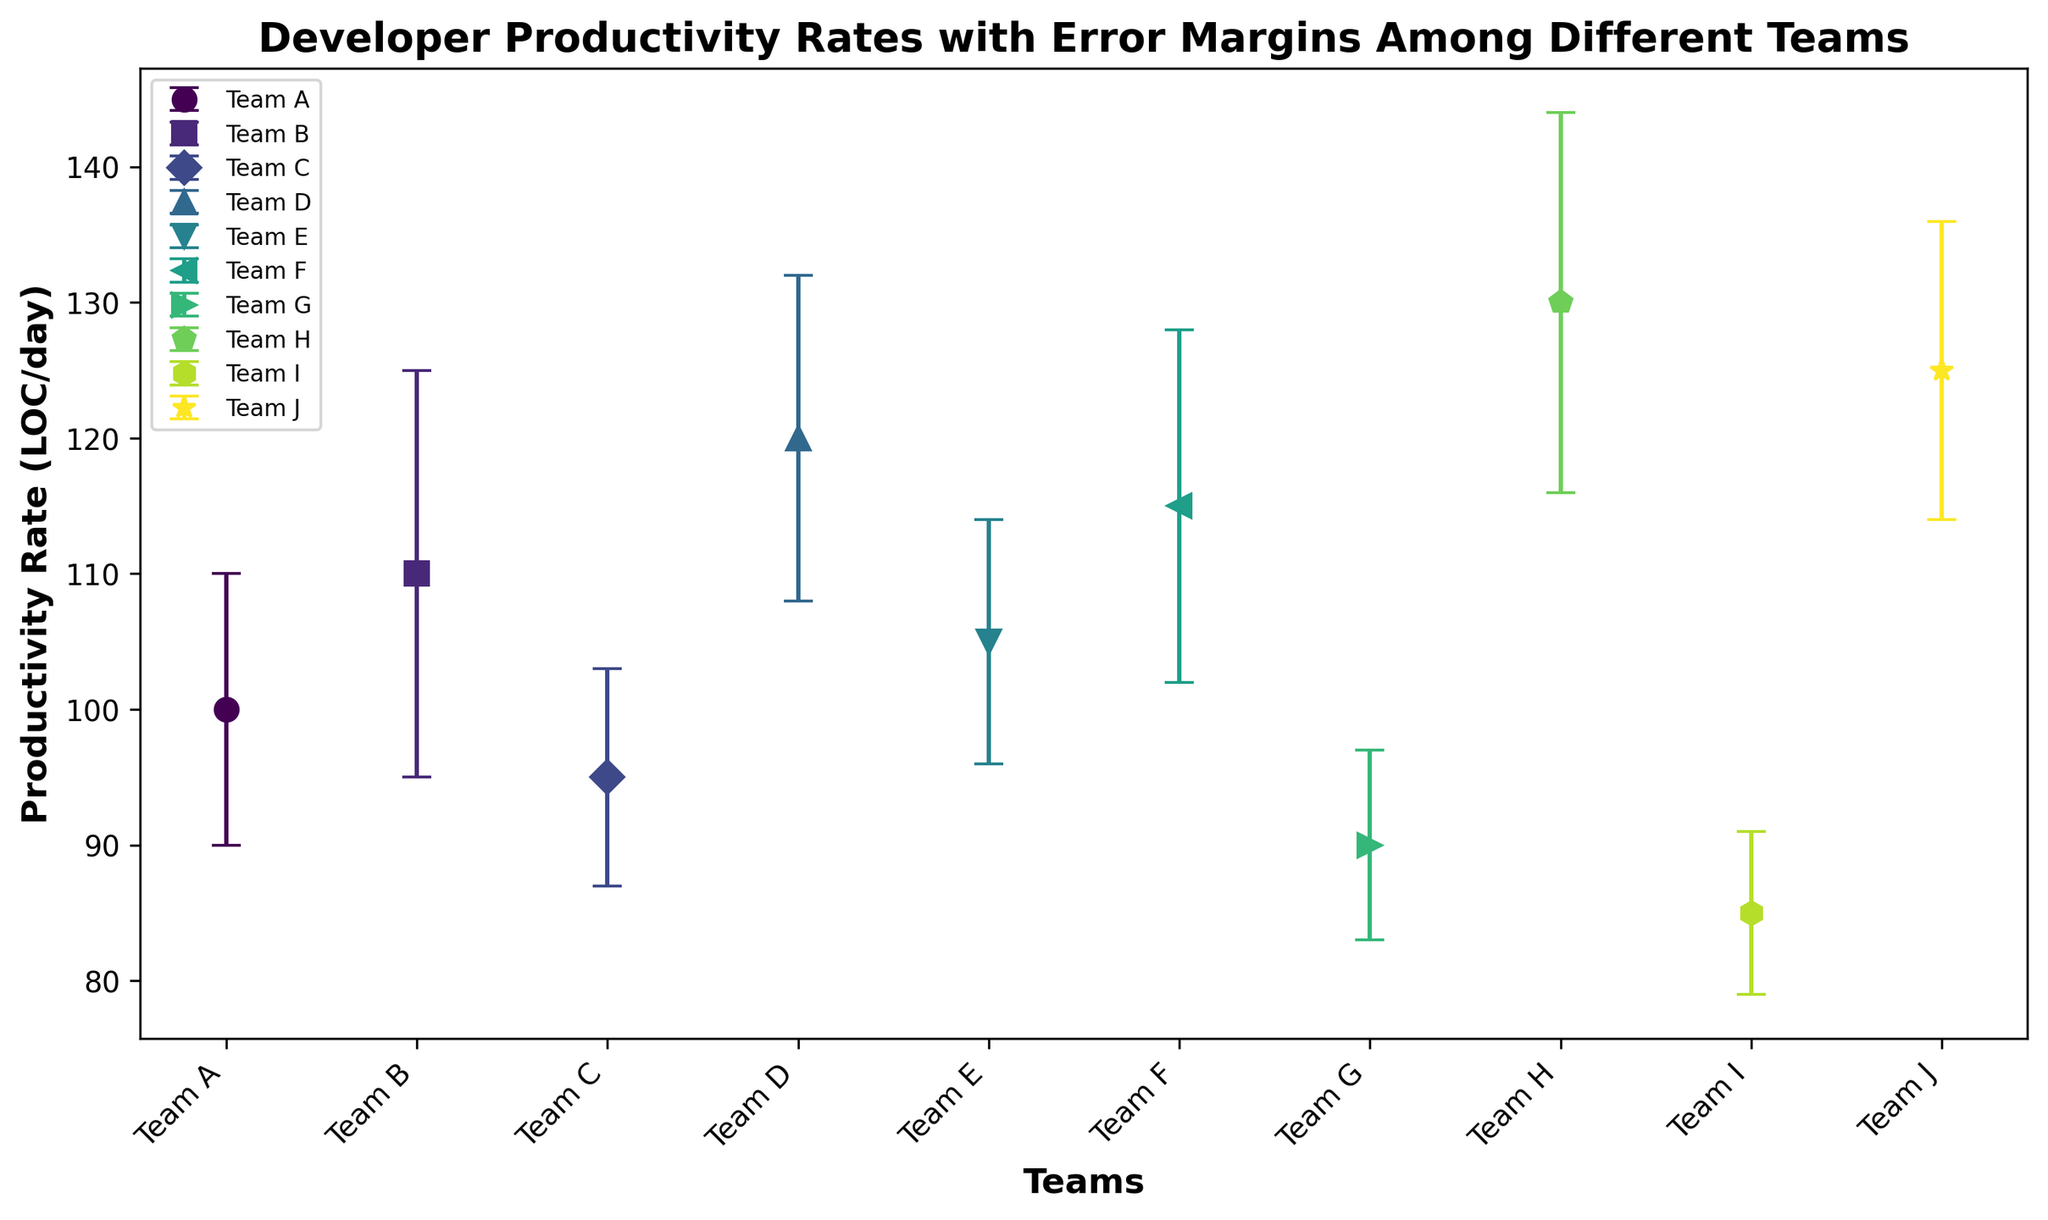What's the highest productivity rate among the teams? Look at all the productivity rate values on the chart and identify the maximum value. Team H has the highest rate at 130 LOC/day.
Answer: 130 LOC/day Which team has the largest error margin? Compare all the error margins on the chart; Team B has the largest error margin at 15 LOC/day.
Answer: Team B What is the difference in productivity rate between Team H and Team I? Refer to the chart for the productivity rates of both teams: Team H has 130 LOC/day and Team I has 85 LOC/day. Subtract the productivity rate of Team I from Team H: 130 - 85 = 45 LOC/day.
Answer: 45 LOC/day Which team has a productivity rate closest to 100 LOC/day? Scan the chart for productivity rates near 100 LOC/day. Team A has a rate of exactly 100 LOC/day.
Answer: Team A How does the error margin of Team D compare to Team G? Look at the error margins for both teams on the chart: Team D has an error margin of 12 LOC/day, and Team G has an error margin of 7 LOC/day. Team D has a larger error margin.
Answer: Team D has a larger error margin What is the average productivity rate among all teams? Sum up the productivity rates of all teams and divide by the number of teams: (100 + 110 + 95 + 120 + 105 + 115 + 90 + 130 + 85 + 125) / 10. Total sum is 1075 LOC/day, and there are 10 teams, so the average is 1075 / 10 = 107.5 LOC/day.
Answer: 107.5 LOC/day Which teams have productivity rates above the average rate? First, find the average productivity rate, which is 107.5 LOC/day as calculated. Then, compare each team's rate to the average and list those above 107.5 LOC/day: Team B (110), Team D (120), Team F (115), Team H (130), Team J (125).
Answer: Team B, Team D, Team F, Team H, Team J Which team's productivity rate is just below Team D? Look at the productivity rate of Team D, which is 120 LOC/day, and find the next highest team below this rate. Team J, with 125 LOC/day, is higher, so Team F with 115 LOC/day is just below.
Answer: Team F What is the range of error margins across all teams? Identify the smallest and largest error margins on the chart. The smallest is 6 LOC/day from Team I, and the largest is 15 LOC/day from Team B. The range is 15 - 6 = 9 LOC/day.
Answer: 9 LOC/day How does Team A's error margin compare to the median error margin of all teams? First, list all error margins in ascending order: (6, 7, 8, 9, 10, 11, 12, 13, 14, 15). The median value, being the middle in an even set, is the average of the 5th and 6th values, which are 10 and 11. So, the median is (10+11)/2 = 10.5 LOC/day. Team A's error margin is 10 LOC/day, slightly below the median.
Answer: Slightly below 